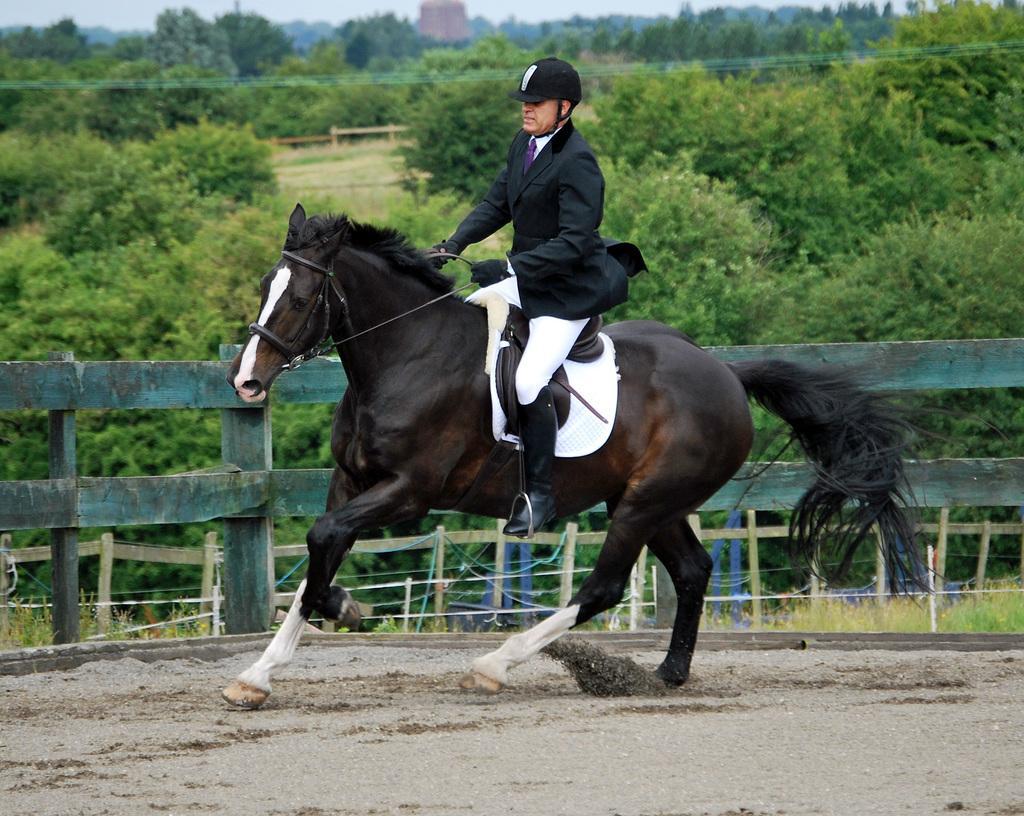How would you summarize this image in a sentence or two? In the foreground of the picture we can see a person riding horse. At the bottom there is soil. In the middle we can see fencing and plants. In the background there are trees, fencing, sky and other objects. 